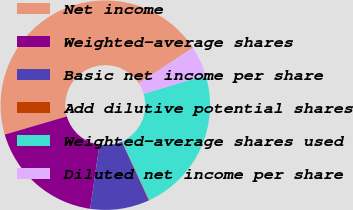Convert chart. <chart><loc_0><loc_0><loc_500><loc_500><pie_chart><fcel>Net income<fcel>Weighted-average shares<fcel>Basic net income per share<fcel>Add dilutive potential shares<fcel>Weighted-average shares used<fcel>Diluted net income per share<nl><fcel>45.3%<fcel>18.17%<fcel>9.13%<fcel>0.09%<fcel>22.69%<fcel>4.61%<nl></chart> 